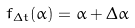<formula> <loc_0><loc_0><loc_500><loc_500>f _ { \Delta t } ( \alpha ) = \alpha + \Delta \alpha</formula> 